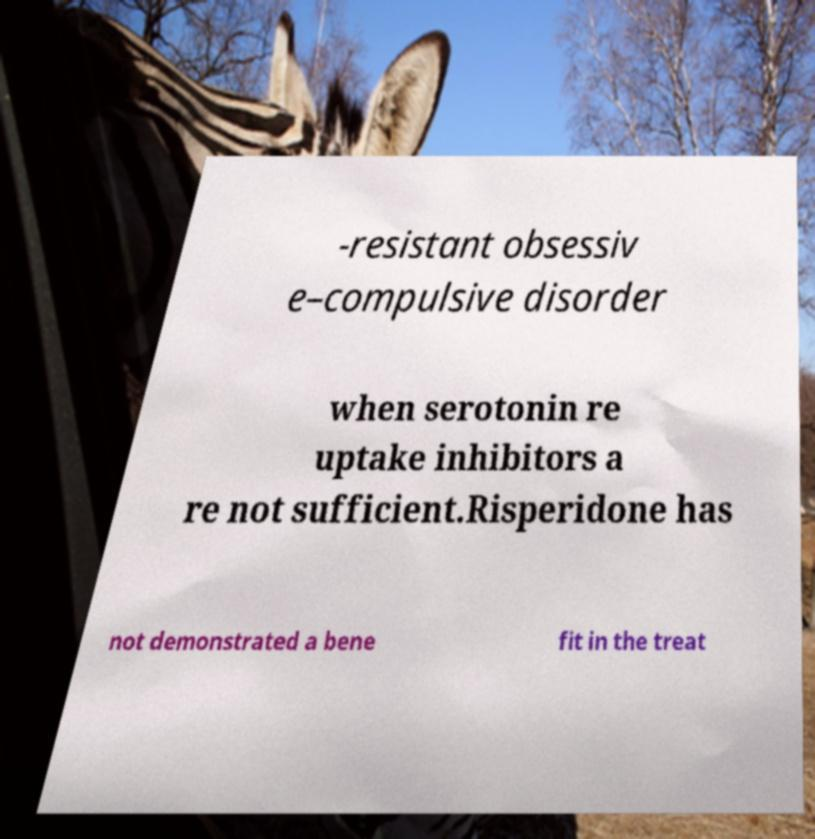Can you read and provide the text displayed in the image?This photo seems to have some interesting text. Can you extract and type it out for me? -resistant obsessiv e–compulsive disorder when serotonin re uptake inhibitors a re not sufficient.Risperidone has not demonstrated a bene fit in the treat 